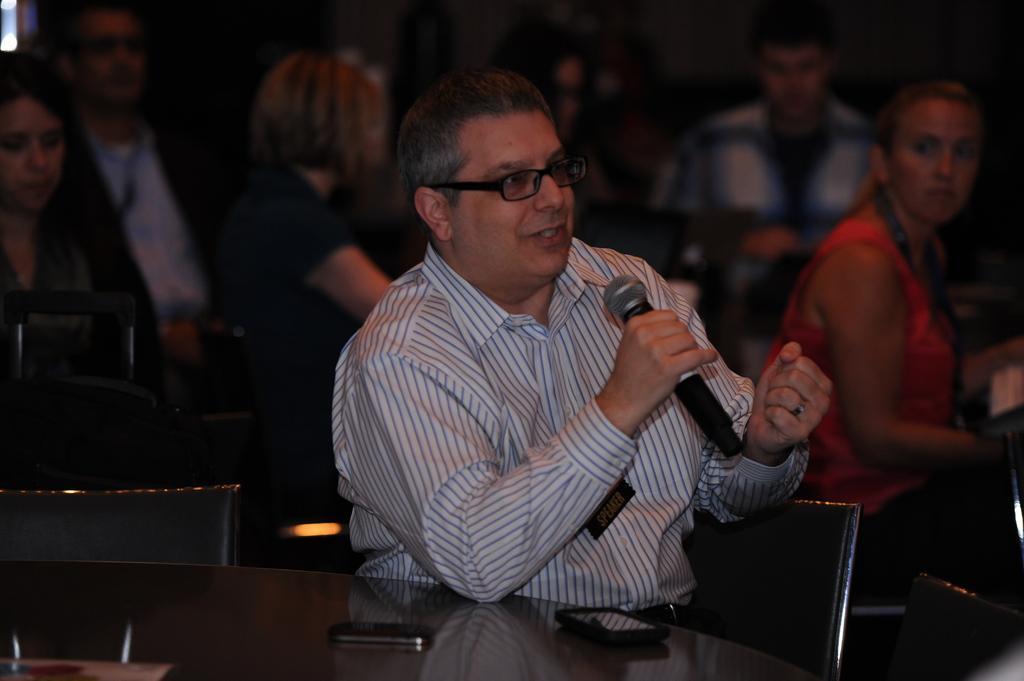Describe this image in one or two sentences. In the foreground of the picture we can see a person sitting in a chair, he is holding a mic. In the background we can see people but they are not clear. 